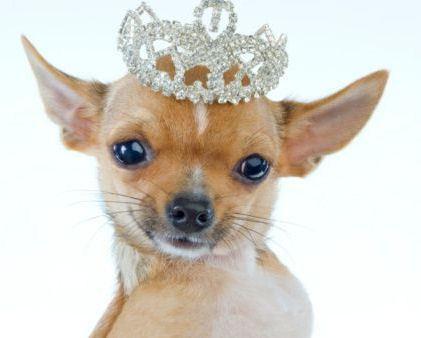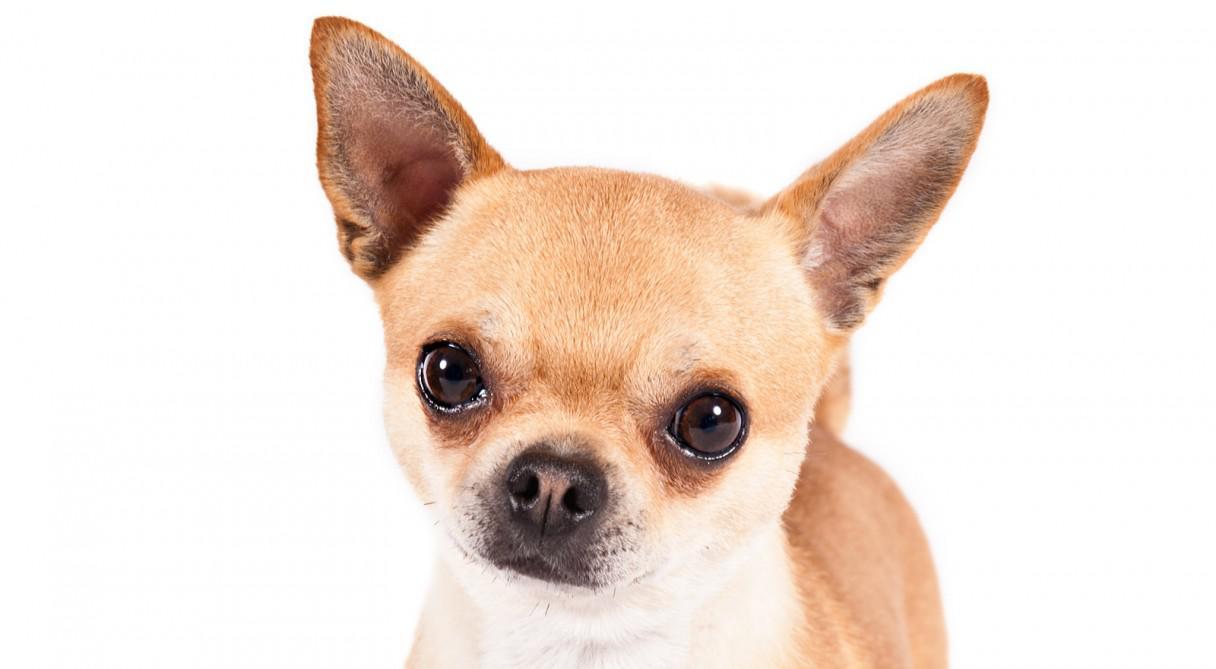The first image is the image on the left, the second image is the image on the right. Evaluate the accuracy of this statement regarding the images: "There is a background in the image to the right.". Is it true? Answer yes or no. No. 